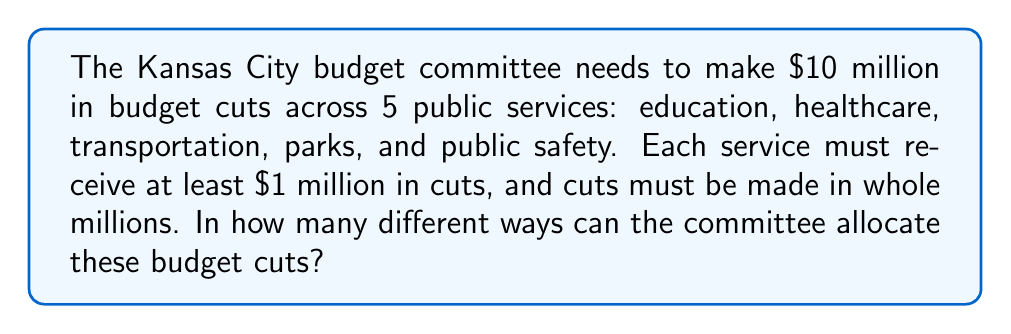Could you help me with this problem? Let's approach this step-by-step:

1) This is a stars and bars problem. We need to distribute $5 million (the remaining amount after allocating $1 million to each service) among 5 services.

2) The formula for stars and bars is:

   $$\binom{n+k-1}{k-1}$$

   where $n$ is the number of identical objects to distribute (stars), and $k$ is the number of groups (bars + 1).

3) In this case:
   $n = 5$ (the remaining $5 million to distribute)
   $k = 5$ (the 5 public services)

4) Plugging into the formula:

   $$\binom{5+5-1}{5-1} = \binom{9}{4}$$

5) Calculate this combination:

   $$\binom{9}{4} = \frac{9!}{4!(9-4)!} = \frac{9!}{4!5!}$$

6) Expand this:

   $$\frac{9 \cdot 8 \cdot 7 \cdot 6 \cdot 5!}{(4 \cdot 3 \cdot 2 \cdot 1) \cdot 5!}$$

7) The 5! cancels out in numerator and denominator:

   $$\frac{9 \cdot 8 \cdot 7 \cdot 6}{4 \cdot 3 \cdot 2 \cdot 1} = \frac{3024}{24} = 126$$

Therefore, there are 126 different ways to allocate the budget cuts.
Answer: 126 